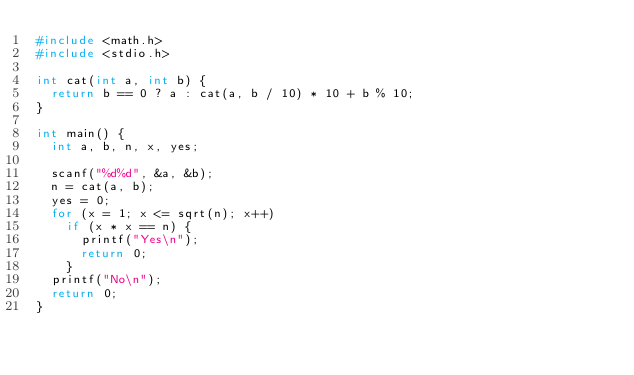Convert code to text. <code><loc_0><loc_0><loc_500><loc_500><_C_>#include <math.h>
#include <stdio.h>

int cat(int a, int b) {
	return b == 0 ? a : cat(a, b / 10) * 10 + b % 10;
}

int main() {
	int a, b, n, x, yes;

	scanf("%d%d", &a, &b);
	n = cat(a, b);
	yes = 0;
	for (x = 1; x <= sqrt(n); x++)
		if (x * x == n) {
			printf("Yes\n");
			return 0;
		}
	printf("No\n");
	return 0;
}
</code> 